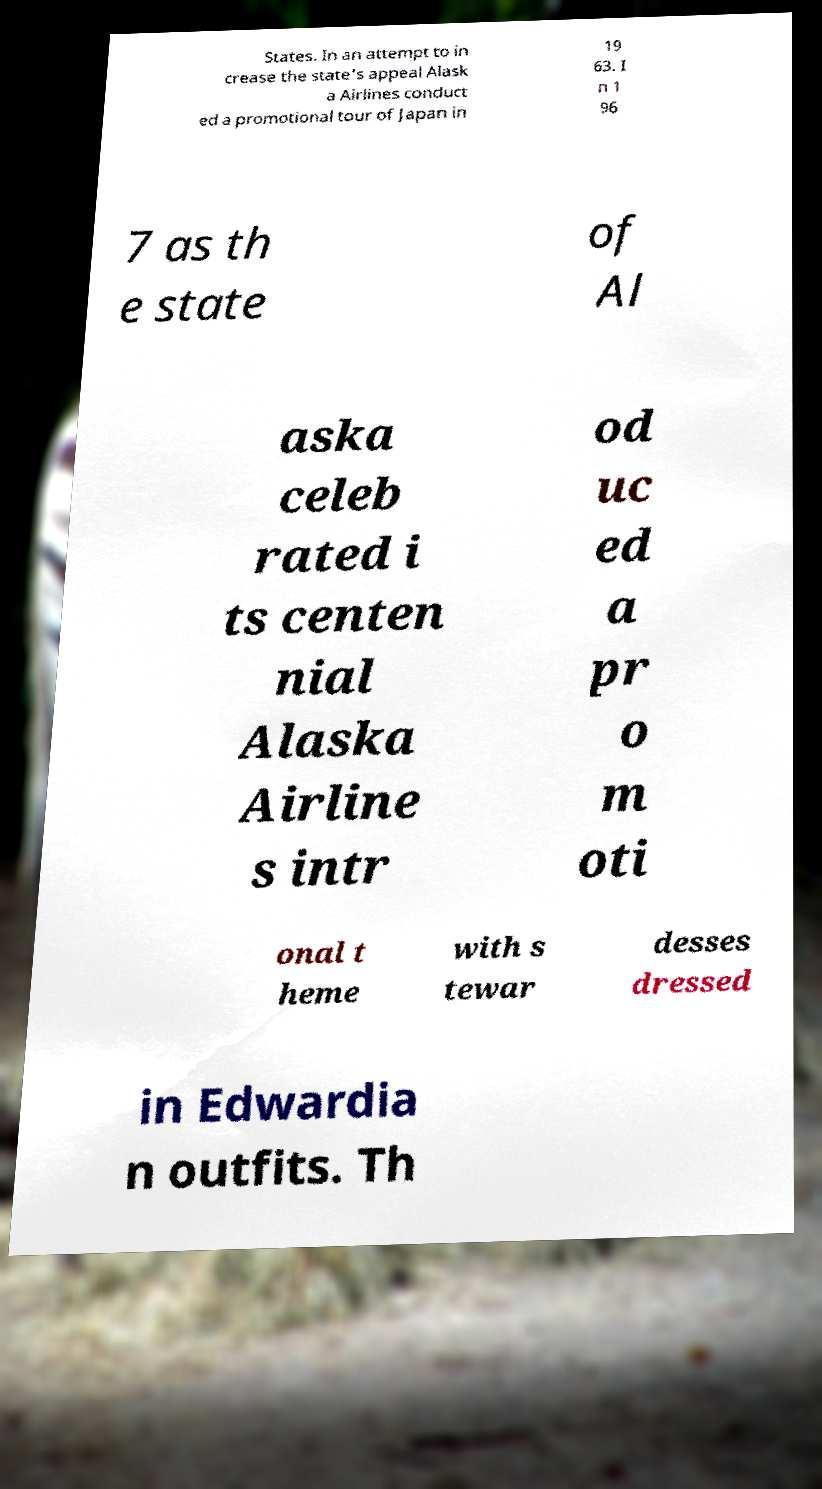For documentation purposes, I need the text within this image transcribed. Could you provide that? States. In an attempt to in crease the state's appeal Alask a Airlines conduct ed a promotional tour of Japan in 19 63. I n 1 96 7 as th e state of Al aska celeb rated i ts centen nial Alaska Airline s intr od uc ed a pr o m oti onal t heme with s tewar desses dressed in Edwardia n outfits. Th 